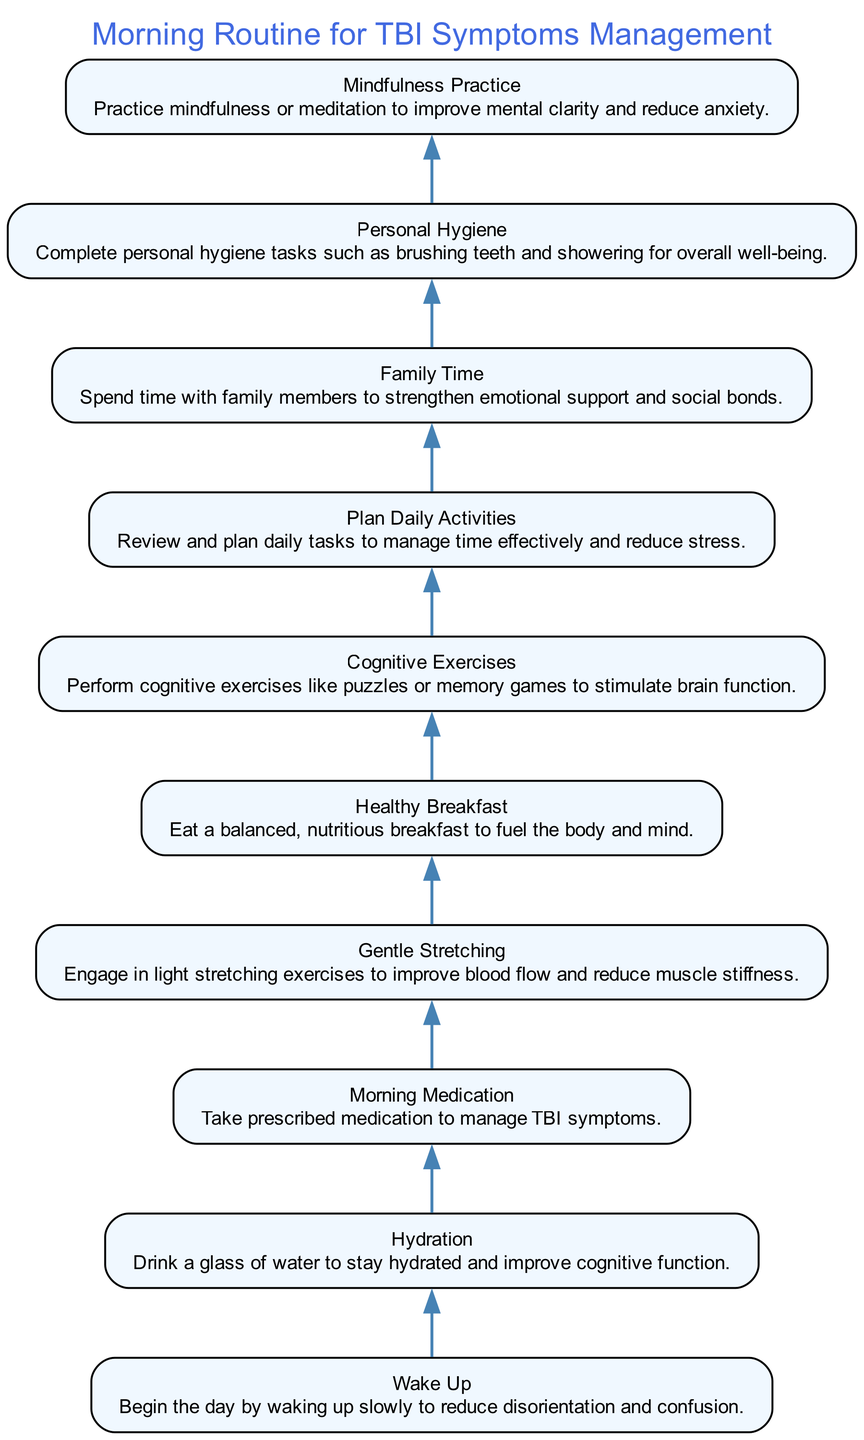What is the first step in the morning routine? The first step is indicated by the bottom-most node of the diagram, which is labeled "Wake Up." It represents the initial action to begin the morning routine.
Answer: Wake Up How many nodes are in the diagram? To find the total number of nodes, count each distinct action listed in the diagram. There are a total of 10 actions represented as nodes.
Answer: 10 What is the action taken after hydration? The flow of the diagram shows that after the "Hydration" node, the next node is "Morning Medication." This direct connection indicates the sequence of actions.
Answer: Morning Medication Which node focuses on reducing muscle stiffness? By reviewing the descriptions of the nodes, "Gentle Stretching" explicitly mentions improving blood flow and reducing muscle stiffness, making it the answer.
Answer: Gentle Stretching What is the last step in the morning routine? The last step is marked by the top-most node, indicating the final action in the flow. The description confirmed which node this refers to.
Answer: Family Time Which two actions focus on cognitive function improvement? To identify the two relevant actions, look for nodes that have keywords related to cognitive operations. "Cognitive Exercises" and "Mindfulness Practice" both emphasize cognitive function improvement.
Answer: Cognitive Exercises and Mindfulness Practice What is the relationship between the nodes "Healthy Breakfast" and "Cognitive Exercises"? The diagram shows that "Healthy Breakfast" leads directly to "Cognitive Exercises." This means that these two activities are sequentially connected in the routine.
Answer: Sequential relationship Which step emphasizes personal care? The node "Personal Hygiene" directly addresses tasks related to personal care and well-being, clearly identifying it as the relevant step in this context.
Answer: Personal Hygiene What is the first health-related action in the morning routine? Analyzing the edges of the diagram from the bottom, after waking up, "Hydration" is the first health-related action to occur.
Answer: Hydration 